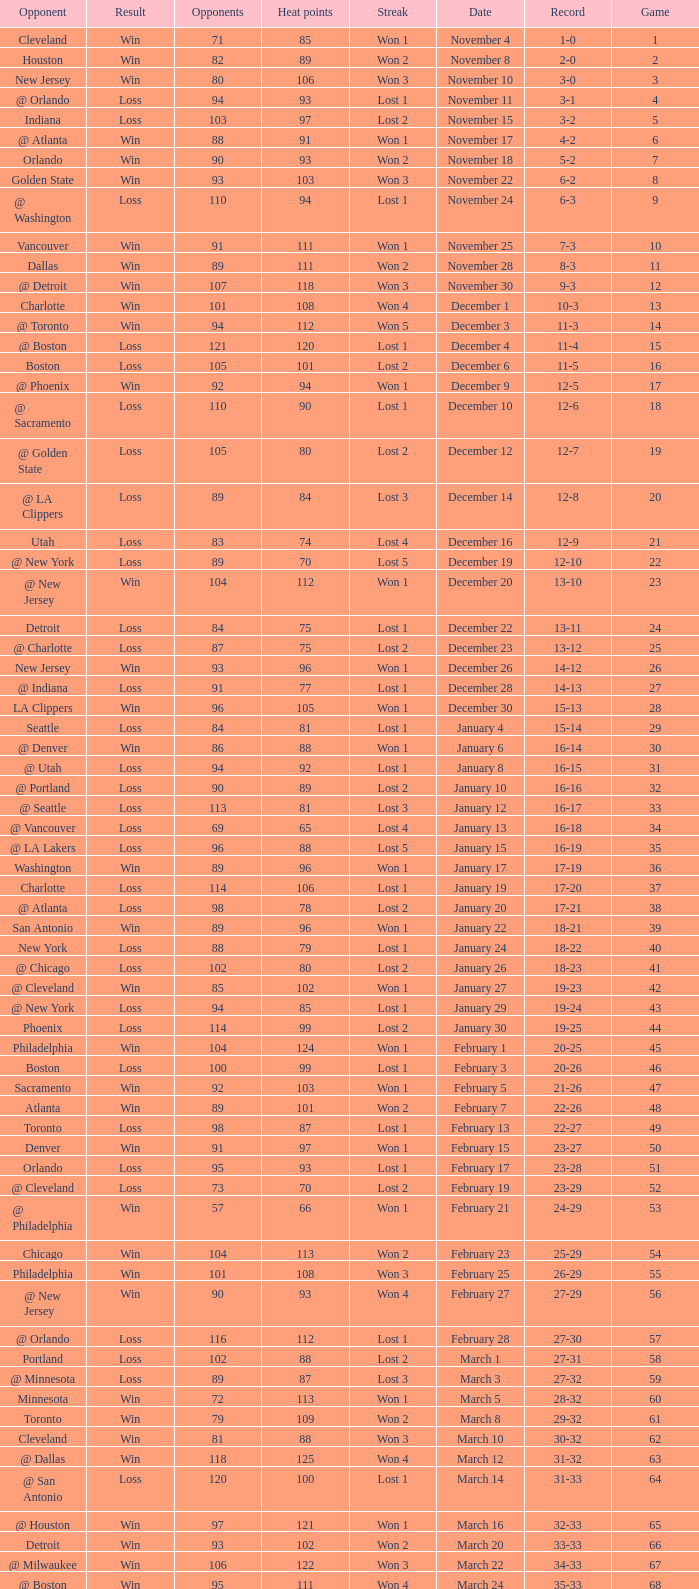What is the average Heat Points, when Result is "Loss", when Game is greater than 72, and when Date is "April 21"? 92.0. 